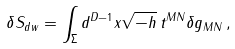<formula> <loc_0><loc_0><loc_500><loc_500>\delta S _ { d w } = \int _ { \Sigma } d ^ { D - 1 } x \sqrt { - h } \, t ^ { M N } \delta g _ { M N } \, ,</formula> 